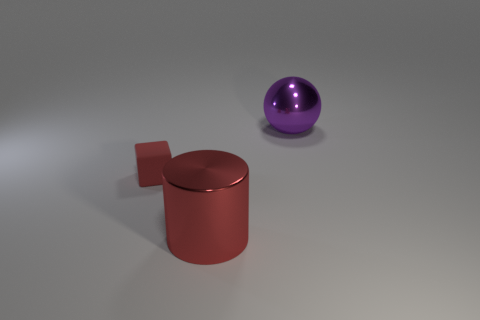Add 3 tiny rubber cubes. How many objects exist? 6 Subtract all cylinders. How many objects are left? 2 Subtract all green cubes. How many blue cylinders are left? 0 Add 3 large red metal things. How many large red metal things are left? 4 Add 2 gray blocks. How many gray blocks exist? 2 Subtract 0 yellow blocks. How many objects are left? 3 Subtract all purple spheres. Subtract all big purple spheres. How many objects are left? 1 